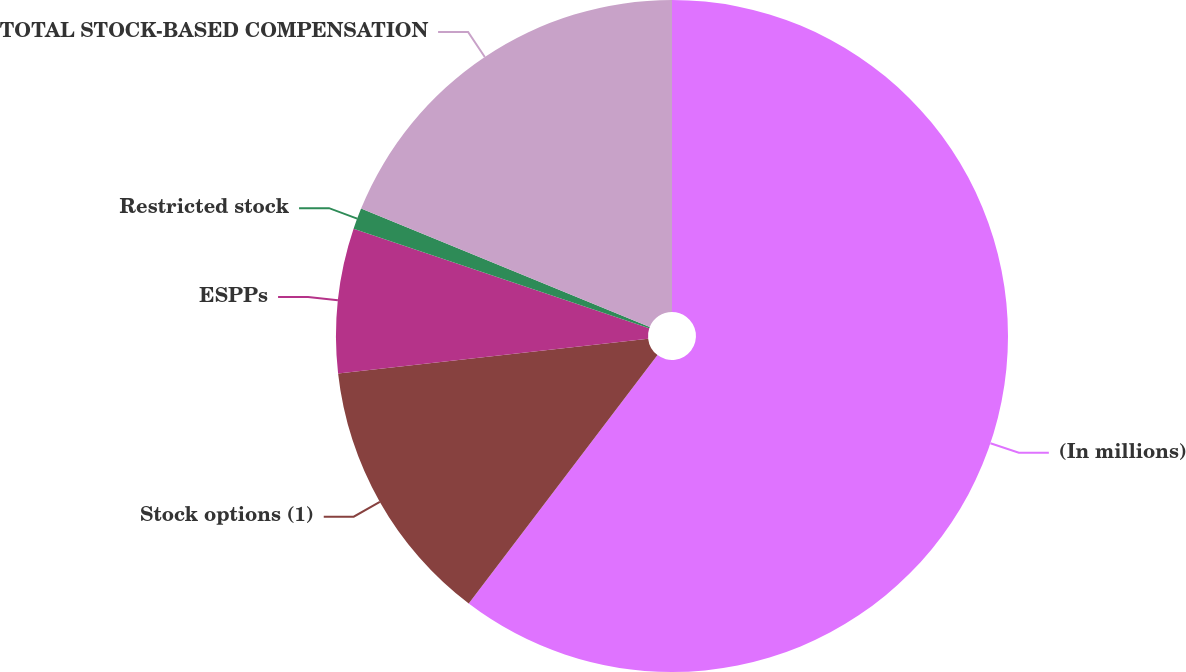Convert chart. <chart><loc_0><loc_0><loc_500><loc_500><pie_chart><fcel>(In millions)<fcel>Stock options (1)<fcel>ESPPs<fcel>Restricted stock<fcel>TOTAL STOCK-BASED COMPENSATION<nl><fcel>60.34%<fcel>12.88%<fcel>6.95%<fcel>1.02%<fcel>18.81%<nl></chart> 